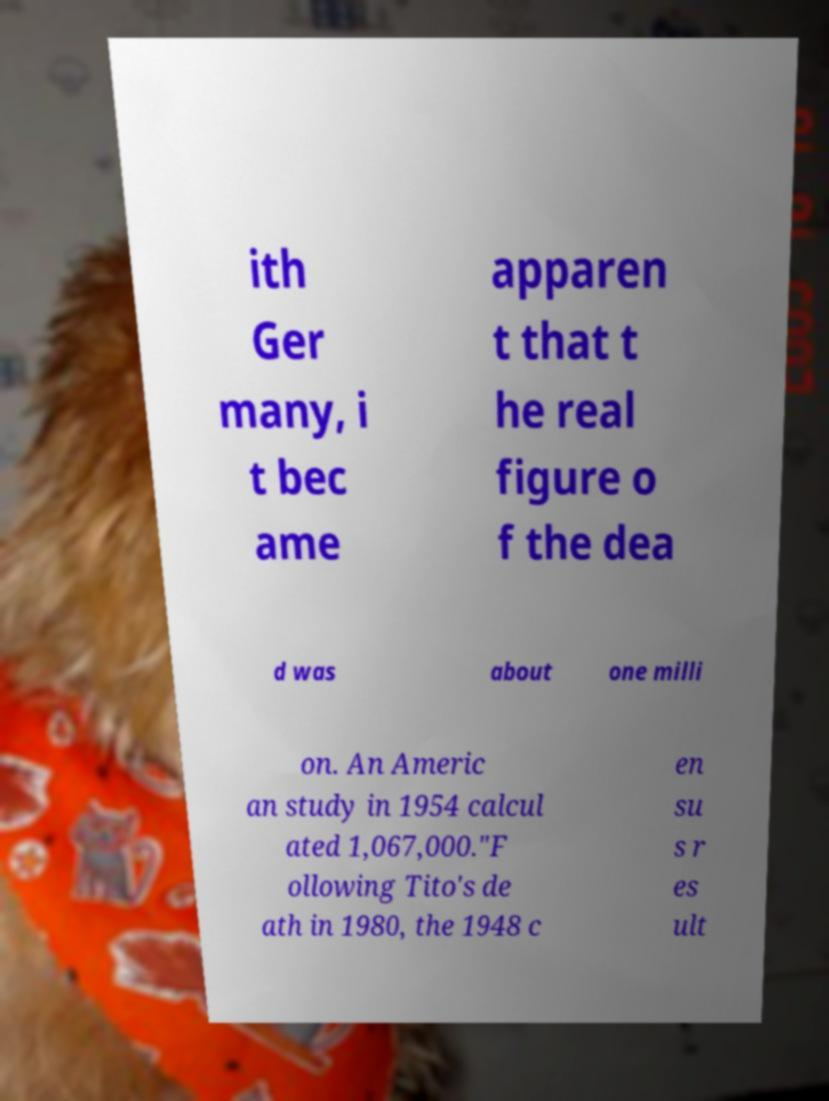Could you assist in decoding the text presented in this image and type it out clearly? ith Ger many, i t bec ame apparen t that t he real figure o f the dea d was about one milli on. An Americ an study in 1954 calcul ated 1,067,000."F ollowing Tito's de ath in 1980, the 1948 c en su s r es ult 